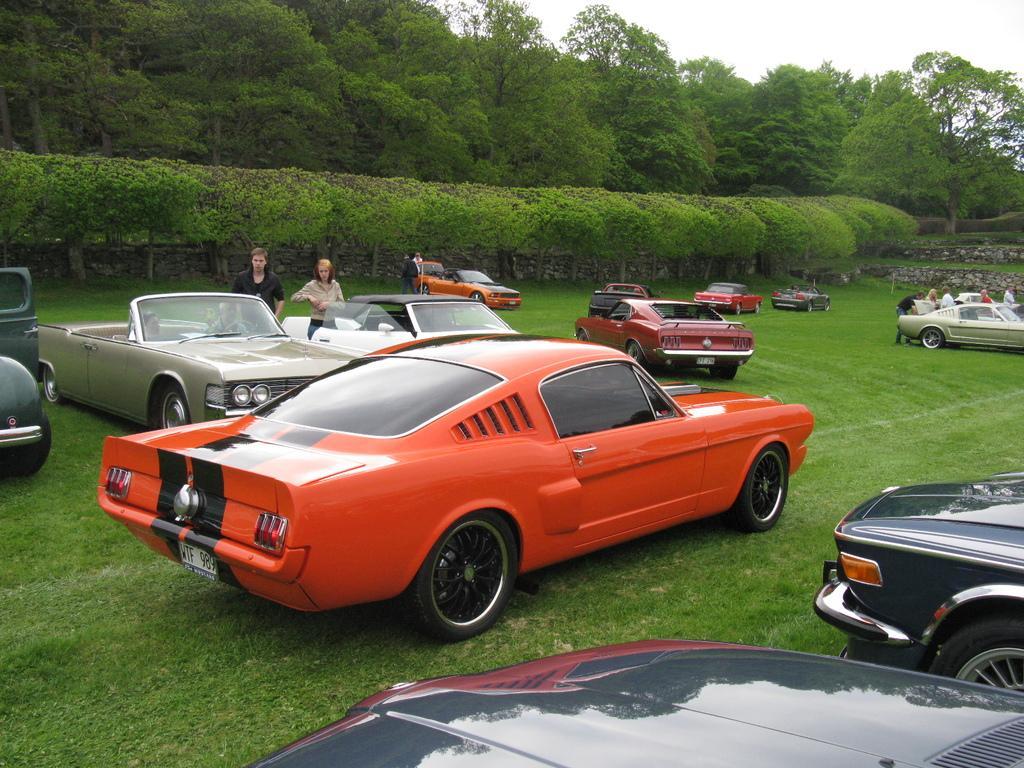Could you give a brief overview of what you see in this image? In the foreground of the picture there are cars, people and grass. In the center of the picture there are trees. In the background there are trees. Sky is cloudy. 